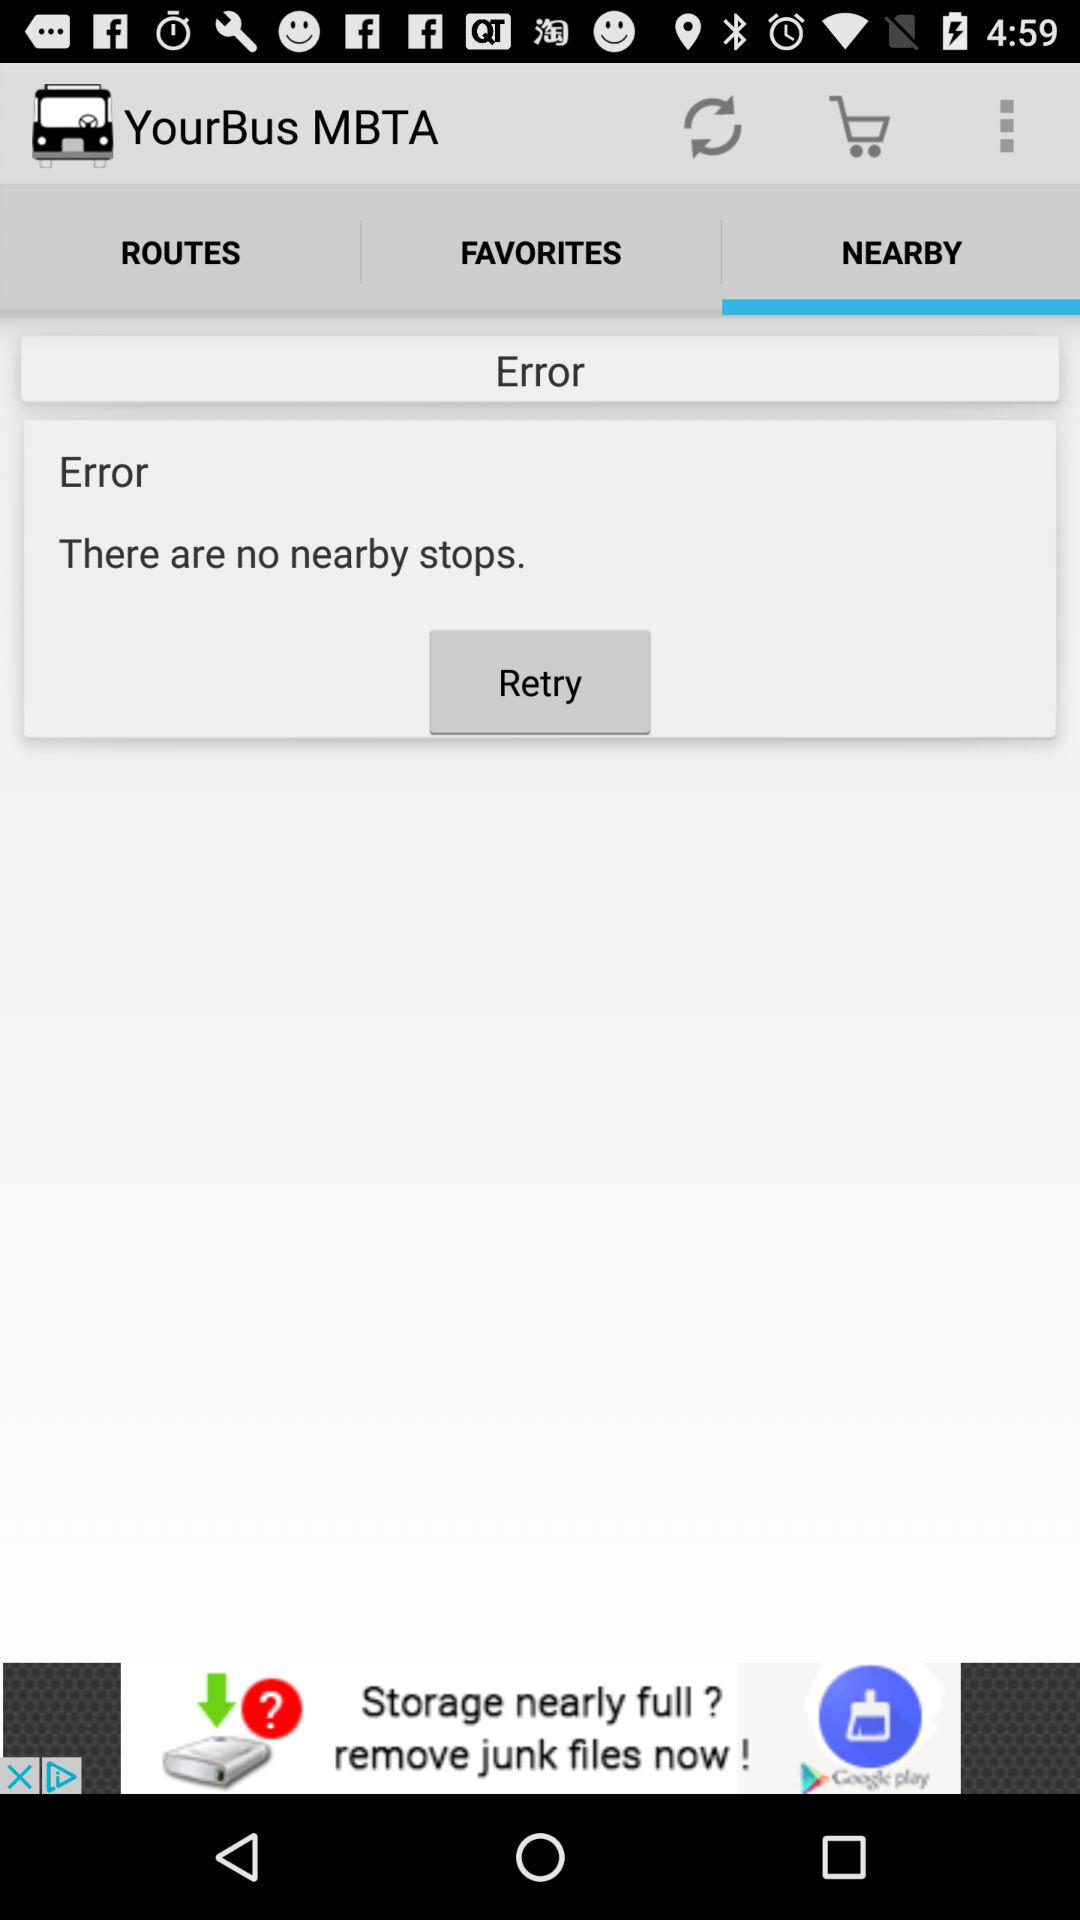Which option is selected? The selected option is "NEARBY". 